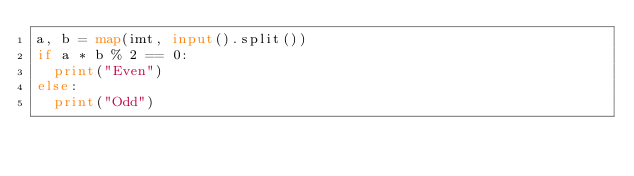<code> <loc_0><loc_0><loc_500><loc_500><_Python_>a, b = map(imt, input().split())
if a * b % 2 == 0:
  print("Even")
else:
  print("Odd")
</code> 